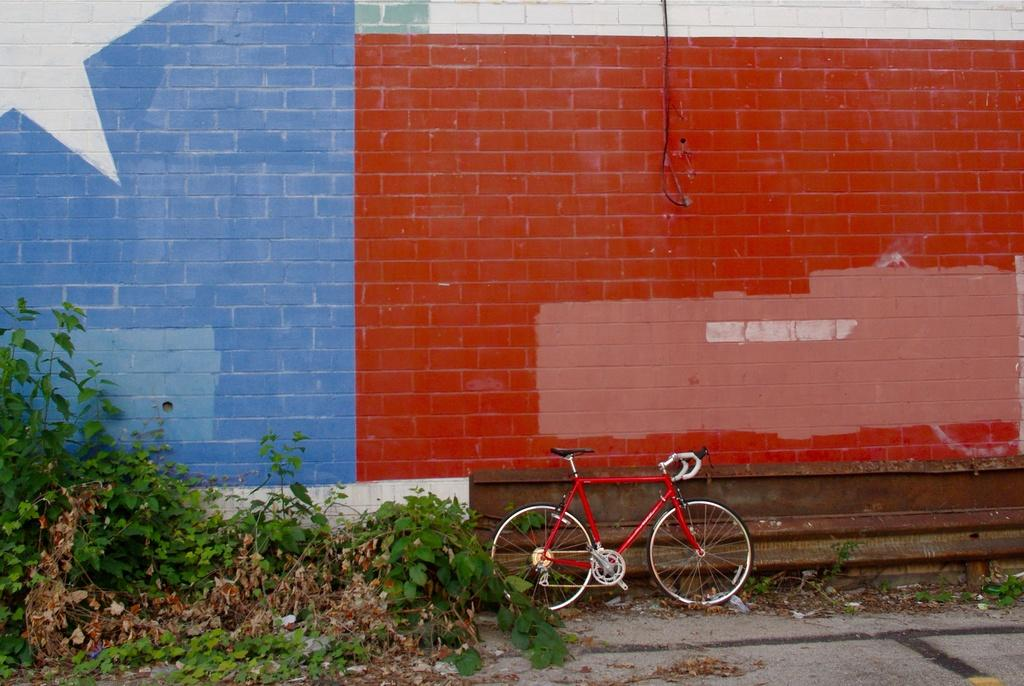What is the main object in the image? There is a bicycle in the image. Where is the bicycle located in relation to other objects? The bicycle is beside a wall. What type of vegetation is present in the image? There are plants in the image. What colors are used to paint the wall in the image? The wall is blue and red in color. What is attached to the wall in the image? There is an object on the wall. Can you tell me how many needles are stuck in the cork on the wall? There is no cork or needle present in the image. 